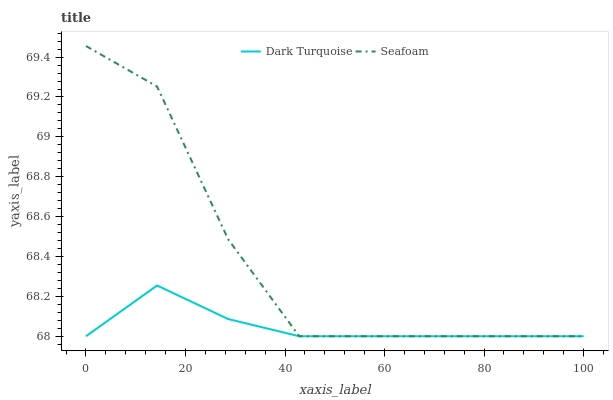Does Seafoam have the minimum area under the curve?
Answer yes or no. No. Is Seafoam the smoothest?
Answer yes or no. No. 